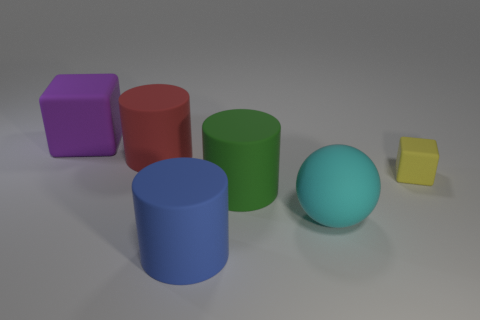Is there anything else that has the same size as the yellow thing?
Give a very brief answer. No. Do the green thing and the big cylinder in front of the cyan rubber object have the same material?
Provide a short and direct response. Yes. Is the shape of the red thing the same as the tiny matte object?
Make the answer very short. No. What color is the large object that is to the right of the big purple rubber object and behind the yellow matte block?
Make the answer very short. Red. What is the color of the tiny rubber block?
Your answer should be very brief. Yellow. Are there any other things of the same shape as the big red object?
Give a very brief answer. Yes. There is a rubber block that is behind the yellow rubber thing; how big is it?
Ensure brevity in your answer.  Large. Are there more big red rubber objects than brown rubber balls?
Ensure brevity in your answer.  Yes. There is a cube that is on the left side of the rubber block that is right of the big ball; what size is it?
Give a very brief answer. Large. The cyan object that is the same size as the purple rubber cube is what shape?
Offer a very short reply. Sphere. 